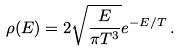Convert formula to latex. <formula><loc_0><loc_0><loc_500><loc_500>\rho ( E ) = 2 \sqrt { \frac { E } { \pi T ^ { 3 } } } e ^ { - E / T } \, .</formula> 